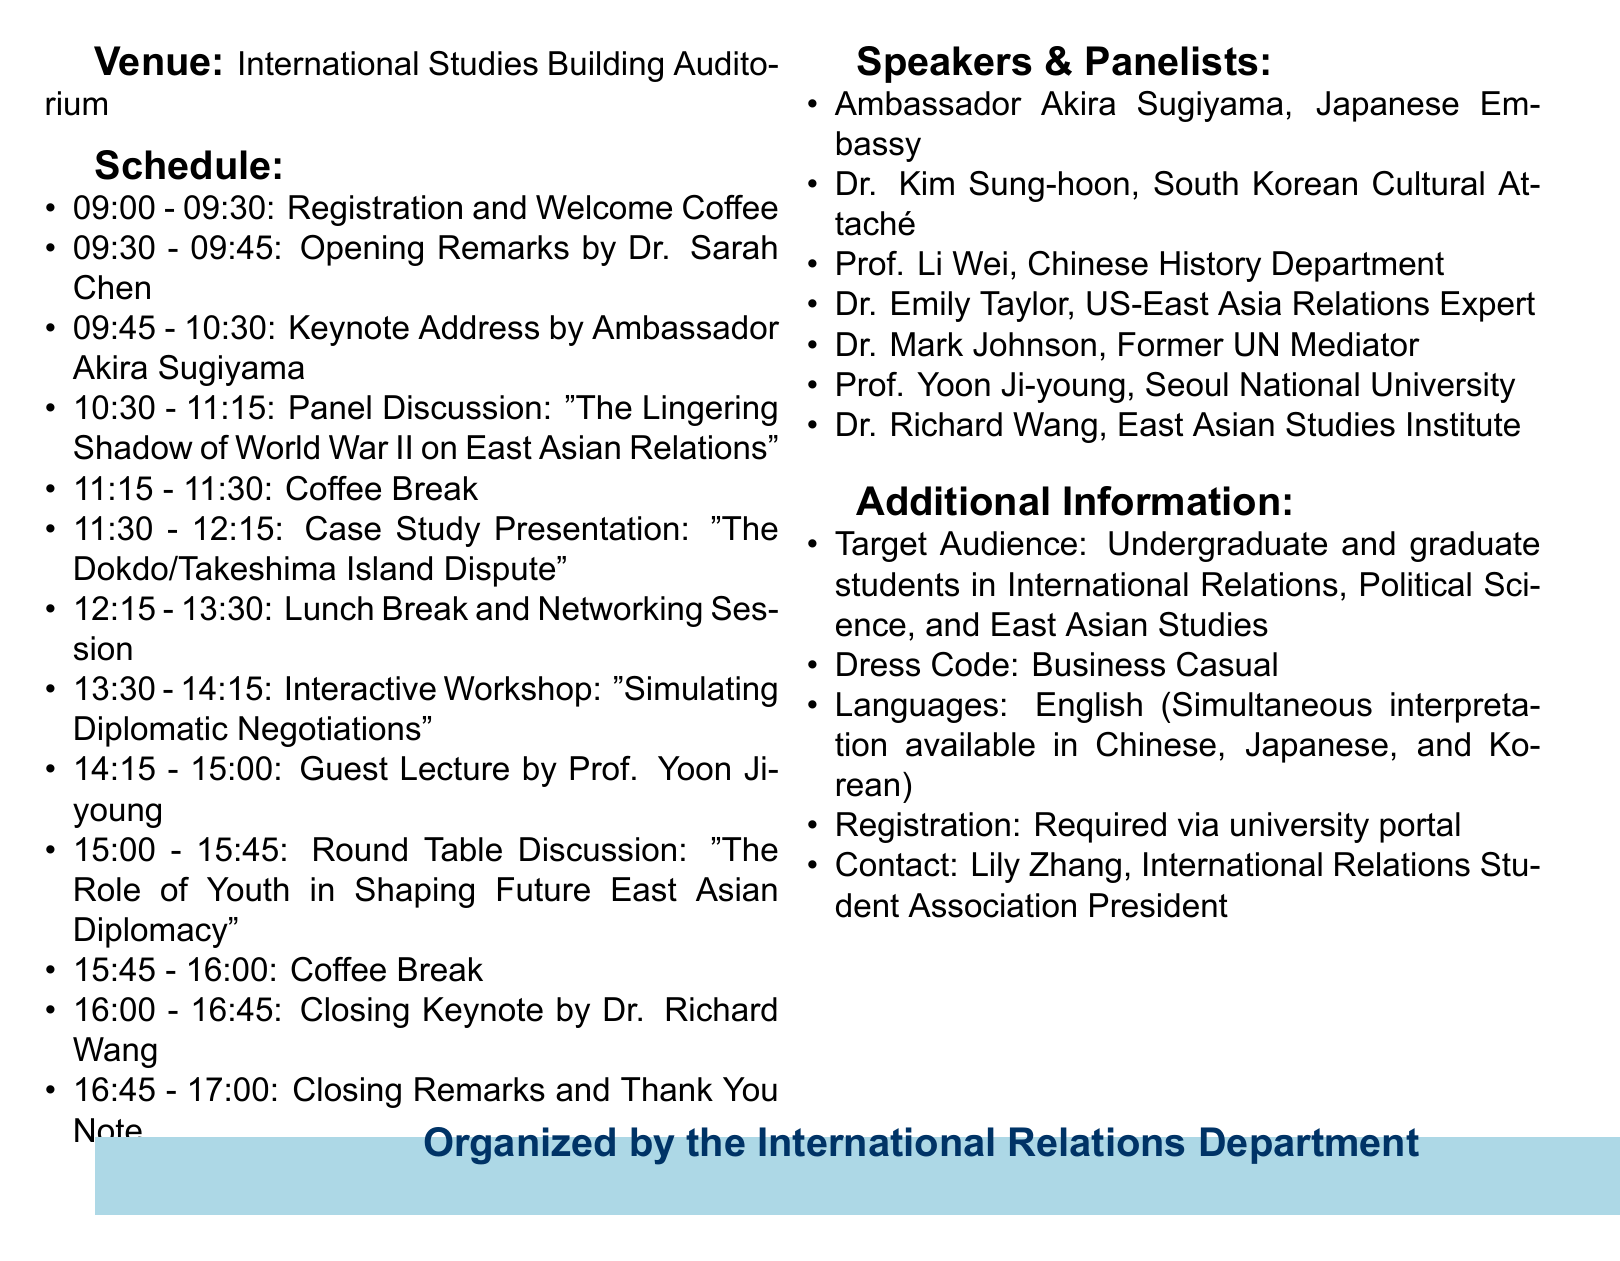What is the date of the seminar? The date of the seminar is mentioned clearly in the document as November 15, 2023.
Answer: November 15, 2023 Where is the seminar being held? The venue for the seminar is specified in the document as the International Studies Building Auditorium.
Answer: International Studies Building Auditorium Who is giving the keynote address? The keynote address is stated to be given by Ambassador Akira Sugiyama from the Japanese Embassy.
Answer: Ambassador Akira Sugiyama What is the title of the panel discussion? The title of the panel discussion is given in the document as "The Lingering Shadow of World War II on East Asian Relations".
Answer: The Lingering Shadow of World War II on East Asian Relations What is the main focus of the seminar? The main focus of the seminar is highlighted in the title, which addresses historical disputes and their impact on modern East Asian diplomacy.
Answer: The Impact of Historical Disputes on Modern East Asian Diplomacy How long is the interactive workshop scheduled for? The duration of the interactive workshop is specified in the schedule as 45 minutes.
Answer: 45 minutes Which languages are available for interpretation? The document explicitly states that simultaneous interpretation is available in Chinese, Japanese, and Korean.
Answer: Chinese, Japanese, and Korean What is required for registration? The document specifies that registration is required via the university portal, indicating a formal registration process.
Answer: Required via university portal Who is the contact person for the seminar? The contact person is mentioned in the additional information section as Lily Zhang, the International Relations Student Association President.
Answer: Lily Zhang 